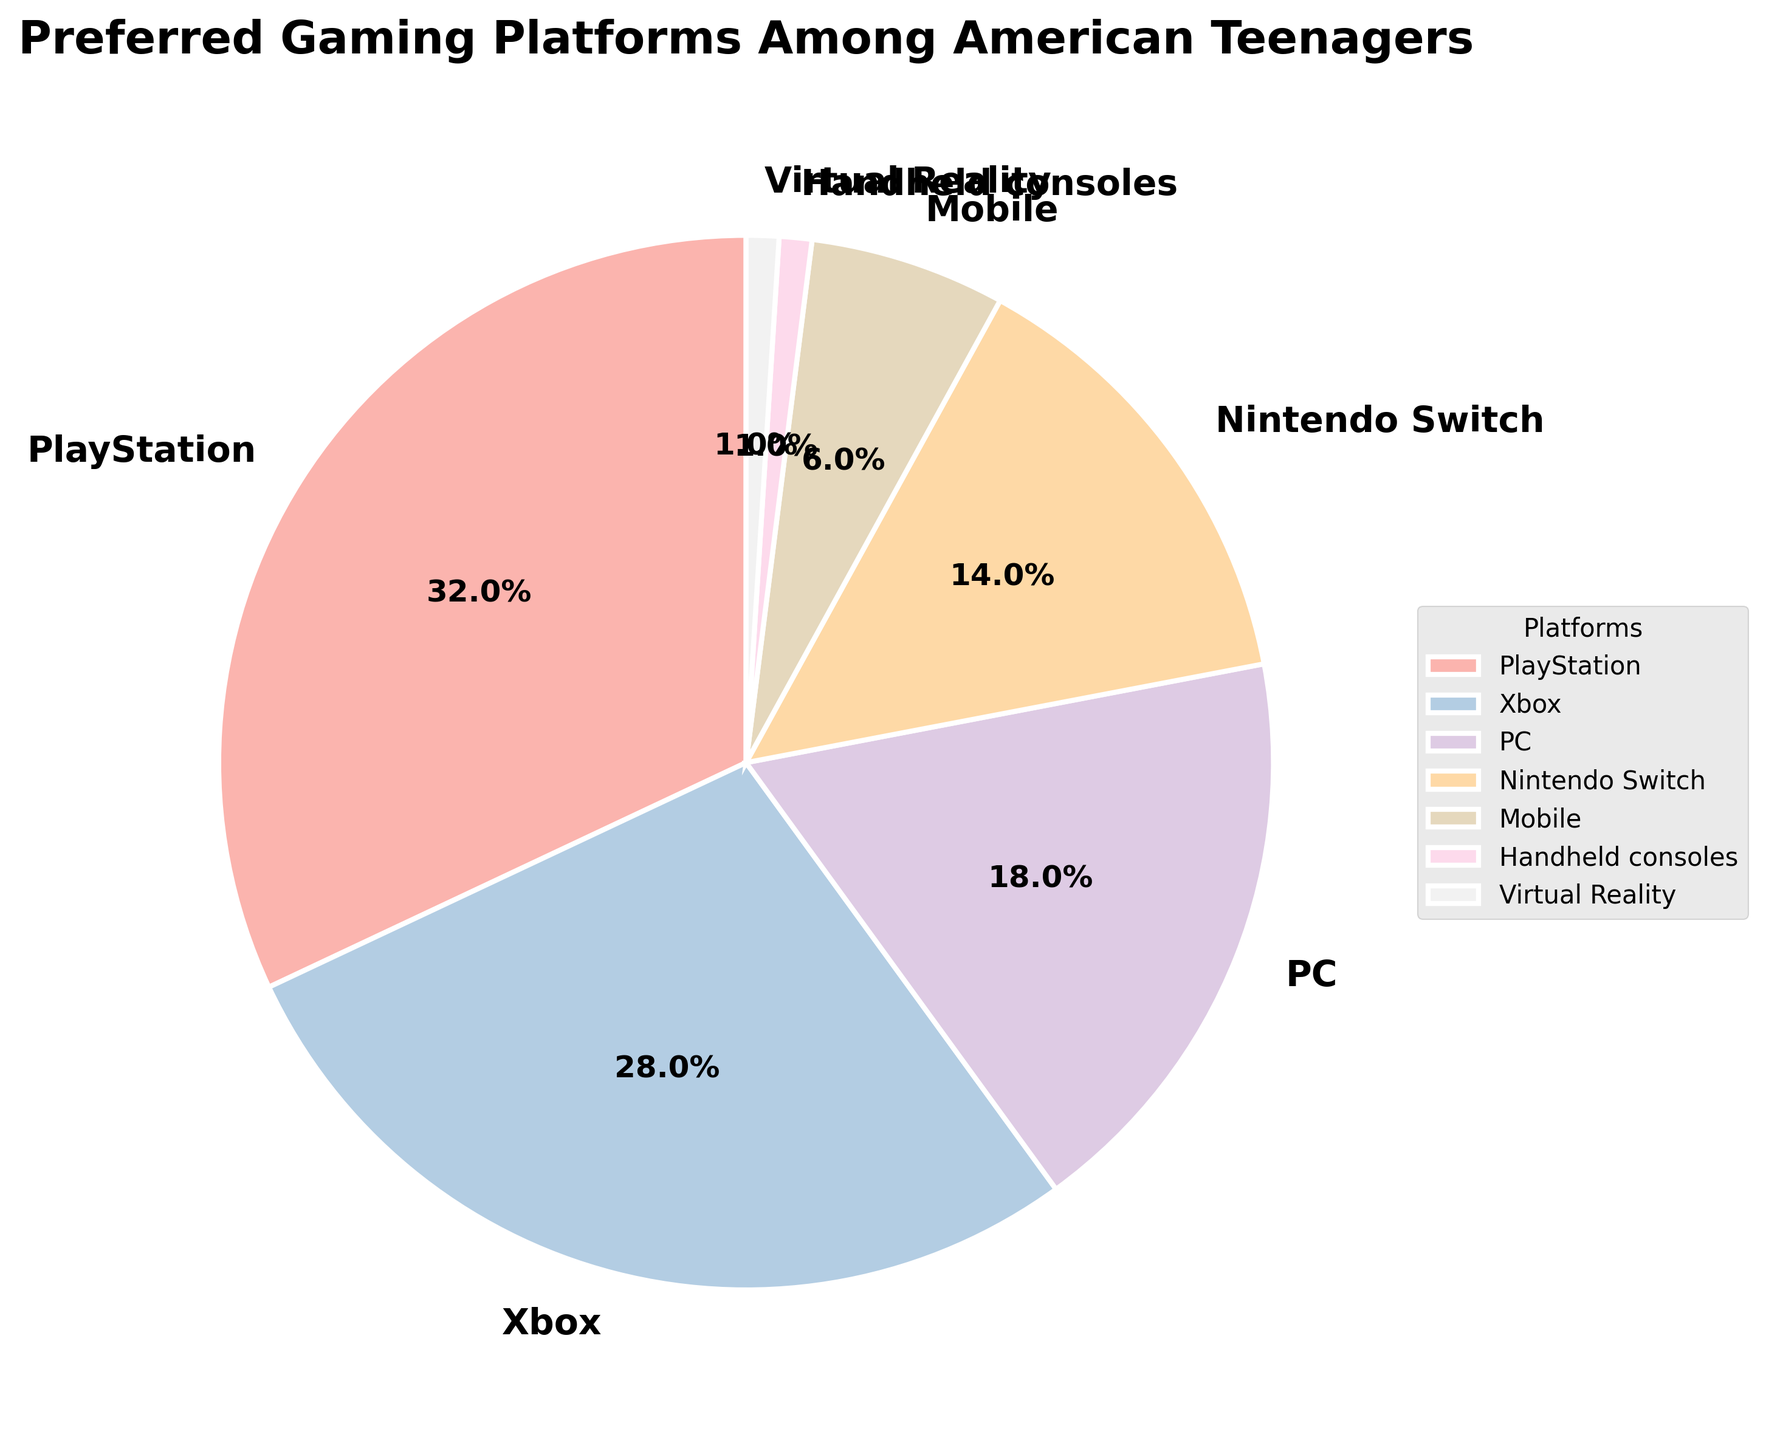Which gaming platform is the most popular? The pie chart shows various gaming platforms with their corresponding percentages. The largest wedge represents PlayStation with 32%.
Answer: PlayStation Which platform has a higher percentage of users: Xbox or PC? Comparing the percentages on the pie chart, Xbox has 28% while PC has 18%. So, Xbox has a higher percentage of users.
Answer: Xbox What's the total percentage for PC, Nintendo Switch, and Mobile combined? Add the percentages of PC, Nintendo Switch, and Mobile: 18% + 14% + 6% = 38%.
Answer: 38% How much more popular is PlayStation compared to Nintendo Switch? Subtract the percentage of Nintendo Switch from PlayStation: 32% - 14% = 18%.
Answer: 18% Which segment is represented by the smallest wedge? The pie chart shows the smallest wedge is shared by both Handheld consoles and Virtual Reality, each with 1%.
Answer: Handheld consoles and Virtual Reality If Mobile usage increased by 2%, how would its new value compare to the PC's percentage? Mobile's new value would be 6% + 2% = 8%. Compare it to PC's current percentage of 18%: 8% is still less than 18%.
Answer: Less than PC What is the difference between the least popular and the most popular platforms? The least popular platforms are Handheld consoles and Virtual Reality each with 1%. The most popular platform is PlayStation with 32%. The difference is 32% - 1% = 31%.
Answer: 31% What's the combined percentage of the top two preferred platforms? The top two platforms are PlayStation with 32% and Xbox with 28%. Combined, they account for 32% + 28% = 60%.
Answer: 60% What percentage of teenagers prefer platforms other than PlayStation and Xbox? Subtract the combined percentage of PlayStation and Xbox from 100%: 100% - (32% + 28%) = 40%.
Answer: 40% If the percentages of all the platforms except Mobile and Handheld consoles are doubled, what would be the new percentage for Virtual Reality? Doubling Virtual Reality's percentage: 1% * 2 = 2%.
Answer: 2% 